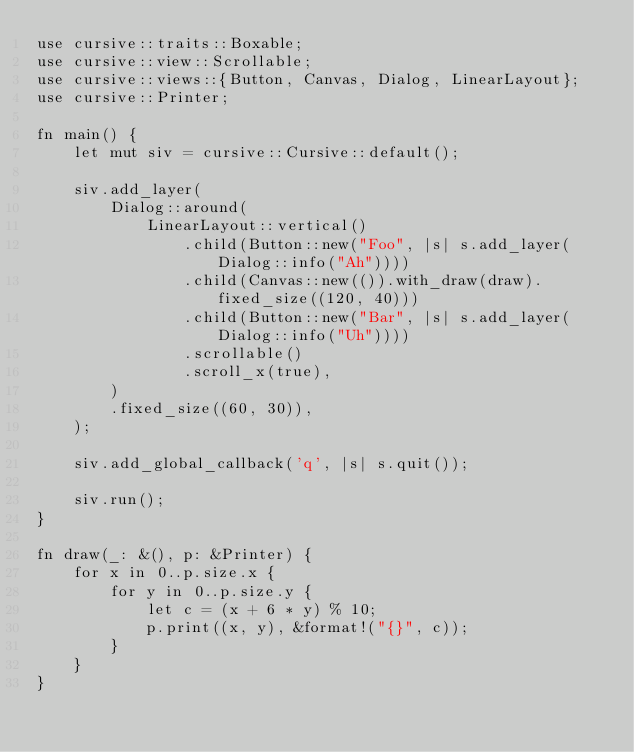Convert code to text. <code><loc_0><loc_0><loc_500><loc_500><_Rust_>use cursive::traits::Boxable;
use cursive::view::Scrollable;
use cursive::views::{Button, Canvas, Dialog, LinearLayout};
use cursive::Printer;

fn main() {
    let mut siv = cursive::Cursive::default();

    siv.add_layer(
        Dialog::around(
            LinearLayout::vertical()
                .child(Button::new("Foo", |s| s.add_layer(Dialog::info("Ah"))))
                .child(Canvas::new(()).with_draw(draw).fixed_size((120, 40)))
                .child(Button::new("Bar", |s| s.add_layer(Dialog::info("Uh"))))
                .scrollable()
                .scroll_x(true),
        )
        .fixed_size((60, 30)),
    );

    siv.add_global_callback('q', |s| s.quit());

    siv.run();
}

fn draw(_: &(), p: &Printer) {
    for x in 0..p.size.x {
        for y in 0..p.size.y {
            let c = (x + 6 * y) % 10;
            p.print((x, y), &format!("{}", c));
        }
    }
}
</code> 